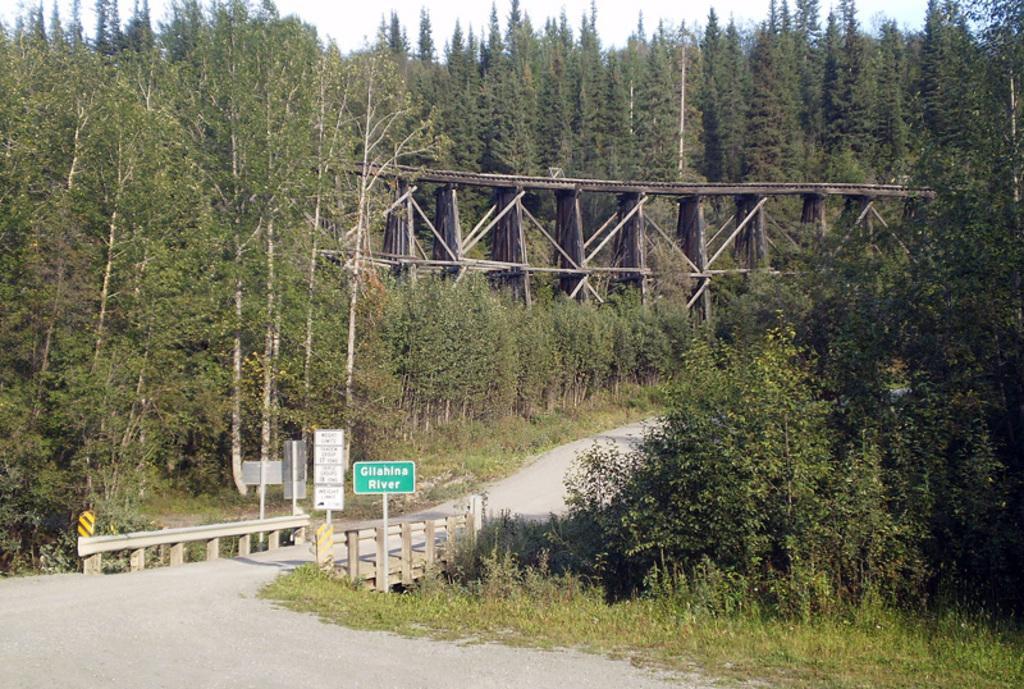Describe this image in one or two sentences. In this image I can see a green color board attached to the pole, background I can see trees in green color, a bridge and the sky is in white color. 